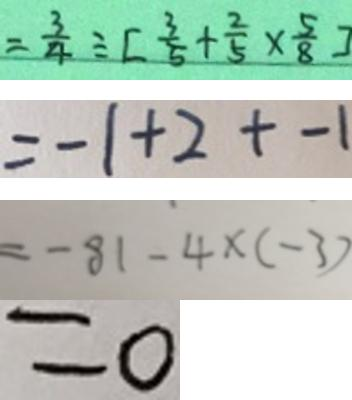<formula> <loc_0><loc_0><loc_500><loc_500>= \frac { 3 } { 4 } \div [ \frac { 3 } { 5 } + \frac { 2 } { 5 } \times \frac { 5 } { 8 } ] 
 = - 1 + 2 + - 1 
 = - 8 1 - 4 \times ( - 3 ) 
 = 0</formula> 